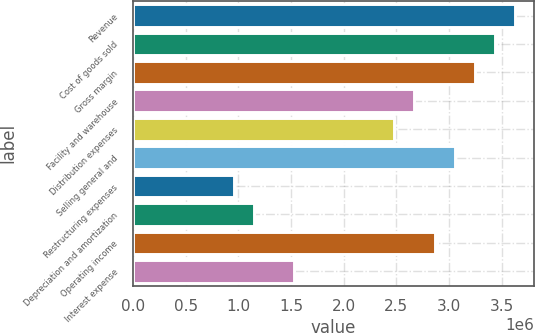<chart> <loc_0><loc_0><loc_500><loc_500><bar_chart><fcel>Revenue<fcel>Cost of goods sold<fcel>Gross margin<fcel>Facility and warehouse<fcel>Distribution expenses<fcel>Selling general and<fcel>Restructuring expenses<fcel>Depreciation and amortization<fcel>Operating income<fcel>Interest expense<nl><fcel>3.62621e+06<fcel>3.43536e+06<fcel>3.2445e+06<fcel>2.67194e+06<fcel>2.48109e+06<fcel>3.05365e+06<fcel>954266<fcel>1.14512e+06<fcel>2.8628e+06<fcel>1.52683e+06<nl></chart> 